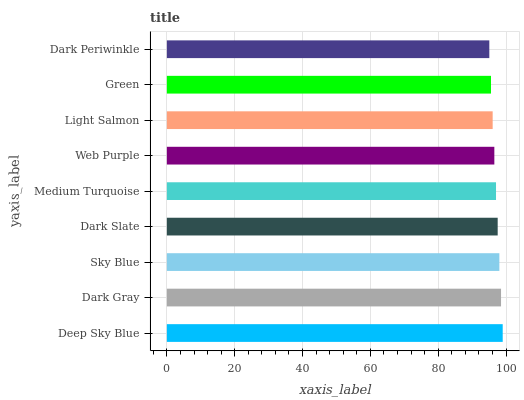Is Dark Periwinkle the minimum?
Answer yes or no. Yes. Is Deep Sky Blue the maximum?
Answer yes or no. Yes. Is Dark Gray the minimum?
Answer yes or no. No. Is Dark Gray the maximum?
Answer yes or no. No. Is Deep Sky Blue greater than Dark Gray?
Answer yes or no. Yes. Is Dark Gray less than Deep Sky Blue?
Answer yes or no. Yes. Is Dark Gray greater than Deep Sky Blue?
Answer yes or no. No. Is Deep Sky Blue less than Dark Gray?
Answer yes or no. No. Is Medium Turquoise the high median?
Answer yes or no. Yes. Is Medium Turquoise the low median?
Answer yes or no. Yes. Is Sky Blue the high median?
Answer yes or no. No. Is Dark Periwinkle the low median?
Answer yes or no. No. 